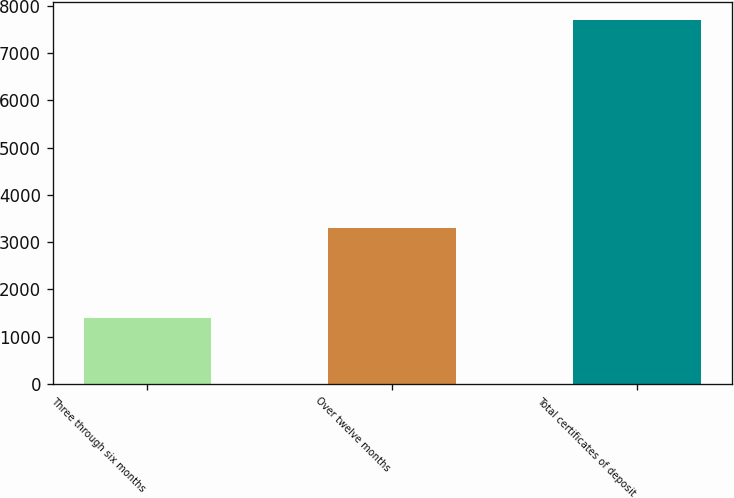Convert chart. <chart><loc_0><loc_0><loc_500><loc_500><bar_chart><fcel>Three through six months<fcel>Over twelve months<fcel>Total certificates of deposit<nl><fcel>1384<fcel>3294<fcel>7702<nl></chart> 